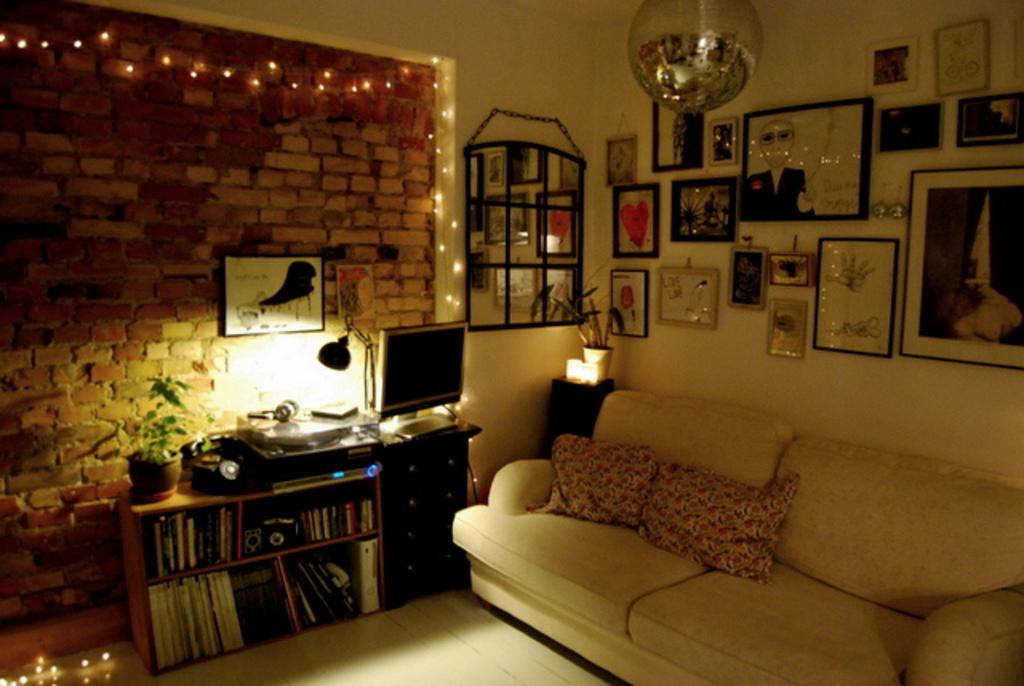What type of furniture is in the image? There is a sofa in the image. What is placed on the sofa? There are pillows on the sofa. What electronic device is visible in the image? There is a monitor in the image. What type of decorations are on the wall? There are photo frames on the wall. What type of greenery is in the image? There is a plant in the image. What type of storage is in the image? There is a bookshelf in the image. What type of flowers are being misted in the image? There are no flowers or misting in the image. 